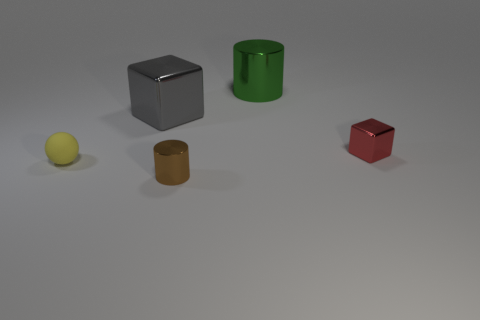Add 4 green shiny cylinders. How many objects exist? 9 Subtract all blocks. How many objects are left? 3 Add 1 shiny blocks. How many shiny blocks exist? 3 Subtract 0 cyan blocks. How many objects are left? 5 Subtract all small green rubber blocks. Subtract all large metallic things. How many objects are left? 3 Add 2 blocks. How many blocks are left? 4 